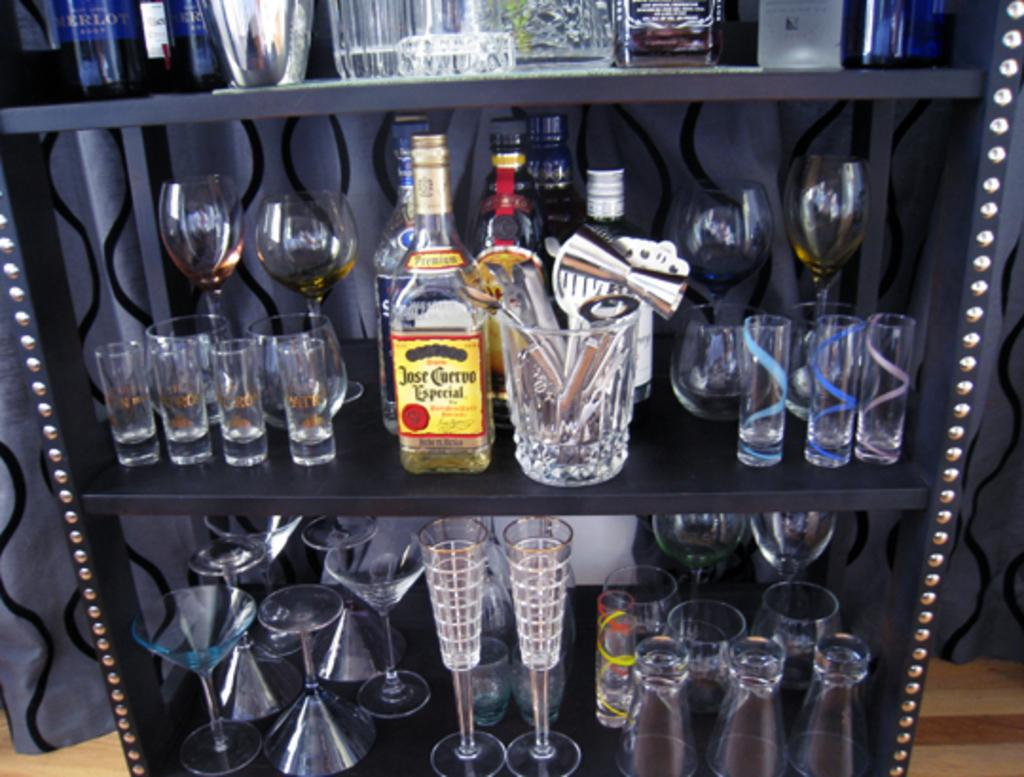What type of table is in the image? There is an iron table in the image. What items are on the table? There are wine bottles and glasses on the table. Can you see a cat playing with powder on the table in the image? There is no cat or powder present on the table in the image. 